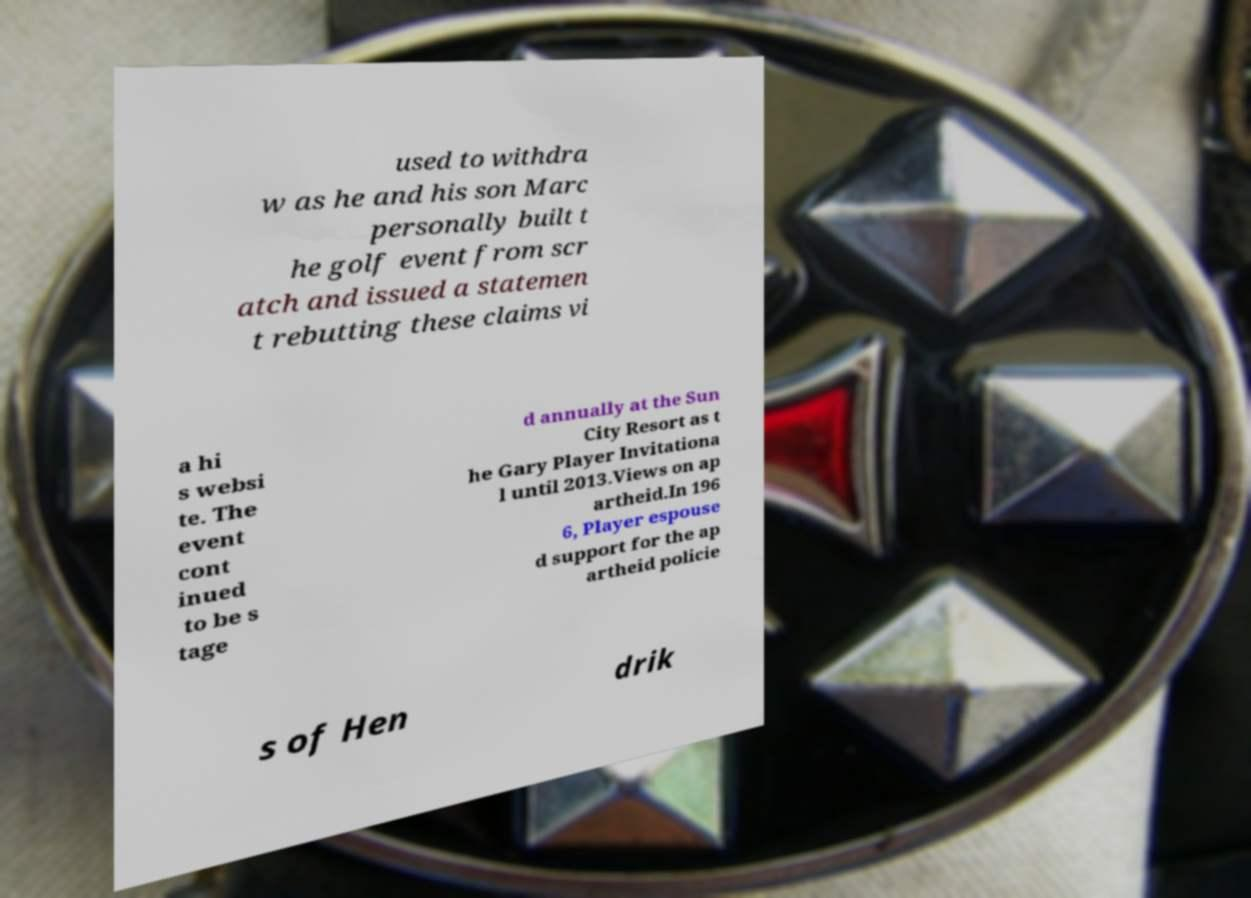What messages or text are displayed in this image? I need them in a readable, typed format. used to withdra w as he and his son Marc personally built t he golf event from scr atch and issued a statemen t rebutting these claims vi a hi s websi te. The event cont inued to be s tage d annually at the Sun City Resort as t he Gary Player Invitationa l until 2013.Views on ap artheid.In 196 6, Player espouse d support for the ap artheid policie s of Hen drik 